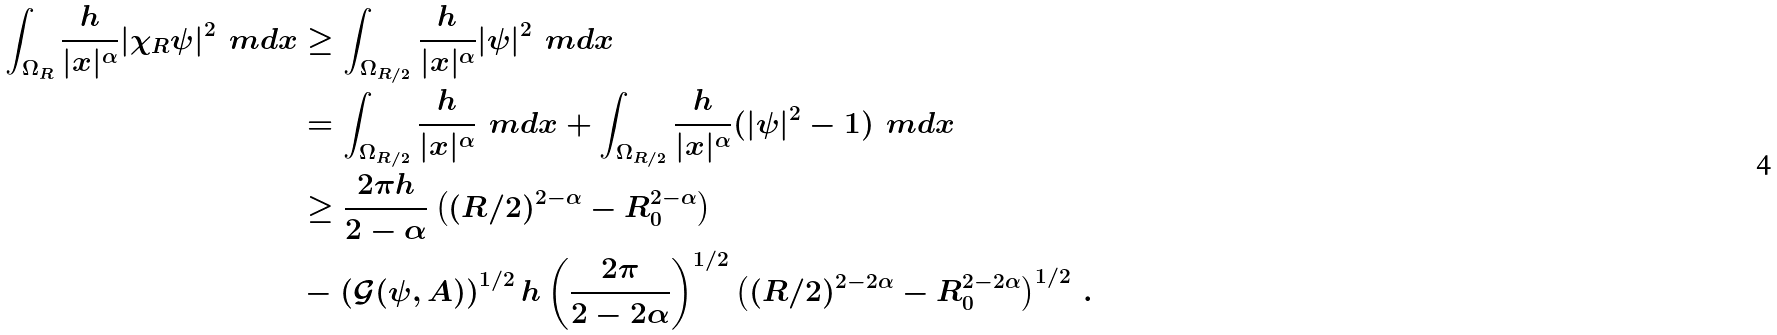Convert formula to latex. <formula><loc_0><loc_0><loc_500><loc_500>\int _ { \Omega _ { R } } \frac { h } { | x | ^ { \alpha } } | \chi _ { R } \psi | ^ { 2 } \, \ m d x & \geq \int _ { \Omega _ { R / 2 } } \frac { h } { | x | ^ { \alpha } } | \psi | ^ { 2 } \, \ m d x \\ & = \int _ { \Omega _ { R / 2 } } \frac { h } { | x | ^ { \alpha } } \, \ m d x + \int _ { \Omega _ { R / 2 } } \frac { h } { | x | ^ { \alpha } } ( | \psi | ^ { 2 } - 1 ) \, \ m d x \\ & \geq \frac { 2 \pi h } { 2 - \alpha } \left ( ( R / 2 ) ^ { 2 - \alpha } - R _ { 0 } ^ { 2 - \alpha } \right ) \\ & - \left ( \mathcal { G } ( \psi , A ) \right ) ^ { 1 / 2 } h \left ( \frac { 2 \pi } { 2 - 2 \alpha } \right ) ^ { 1 / 2 } \left ( ( R / 2 ) ^ { 2 - 2 \alpha } - R _ { 0 } ^ { 2 - 2 \alpha } \right ) ^ { 1 / 2 } \, .</formula> 